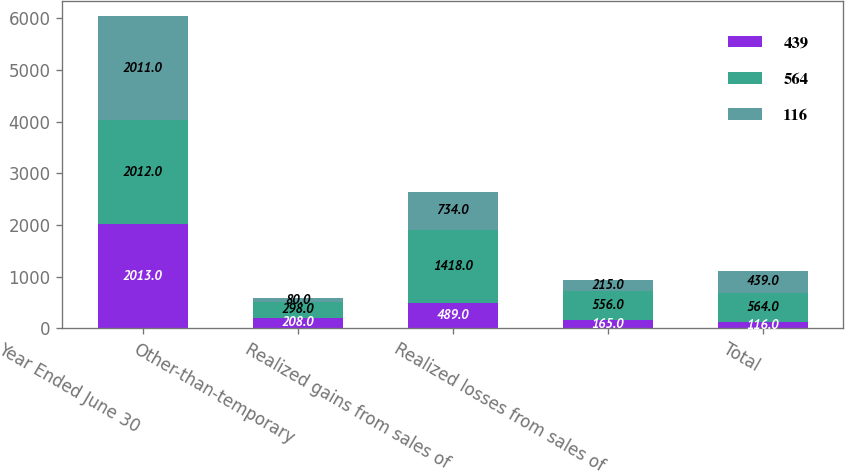Convert chart to OTSL. <chart><loc_0><loc_0><loc_500><loc_500><stacked_bar_chart><ecel><fcel>Year Ended June 30<fcel>Other-than-temporary<fcel>Realized gains from sales of<fcel>Realized losses from sales of<fcel>Total<nl><fcel>439<fcel>2013<fcel>208<fcel>489<fcel>165<fcel>116<nl><fcel>564<fcel>2012<fcel>298<fcel>1418<fcel>556<fcel>564<nl><fcel>116<fcel>2011<fcel>80<fcel>734<fcel>215<fcel>439<nl></chart> 